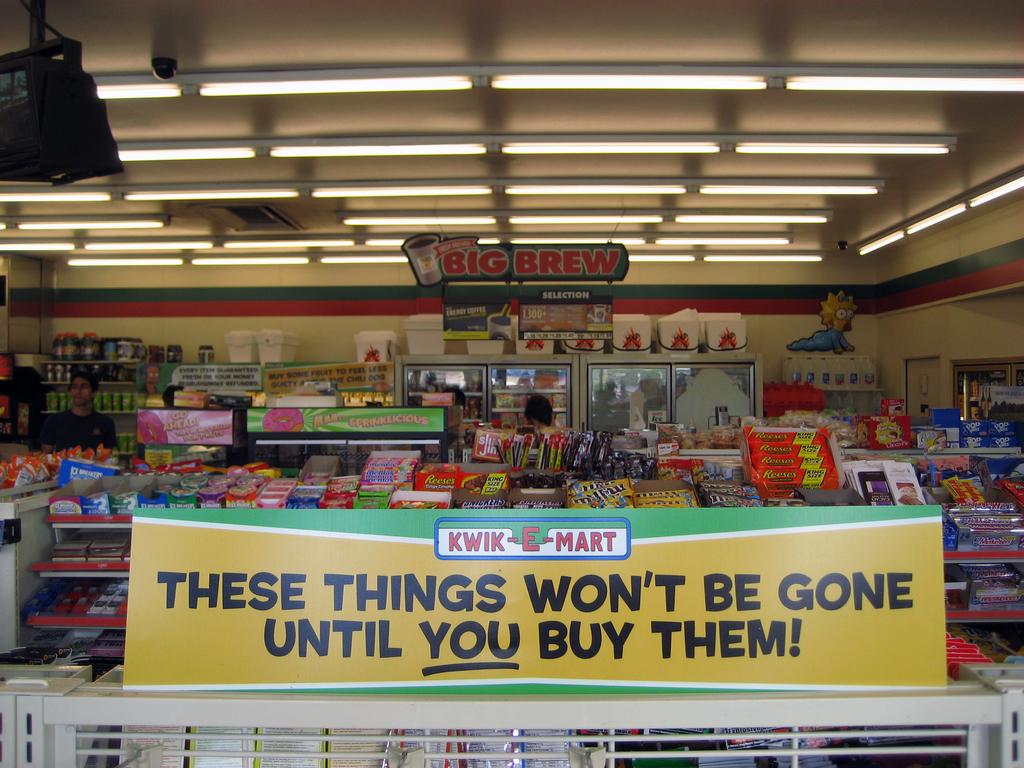What is the name of this mart?
Your response must be concise. Kwik e mart. Whats the name of this mart?
Your answer should be compact. Kwik mart. 